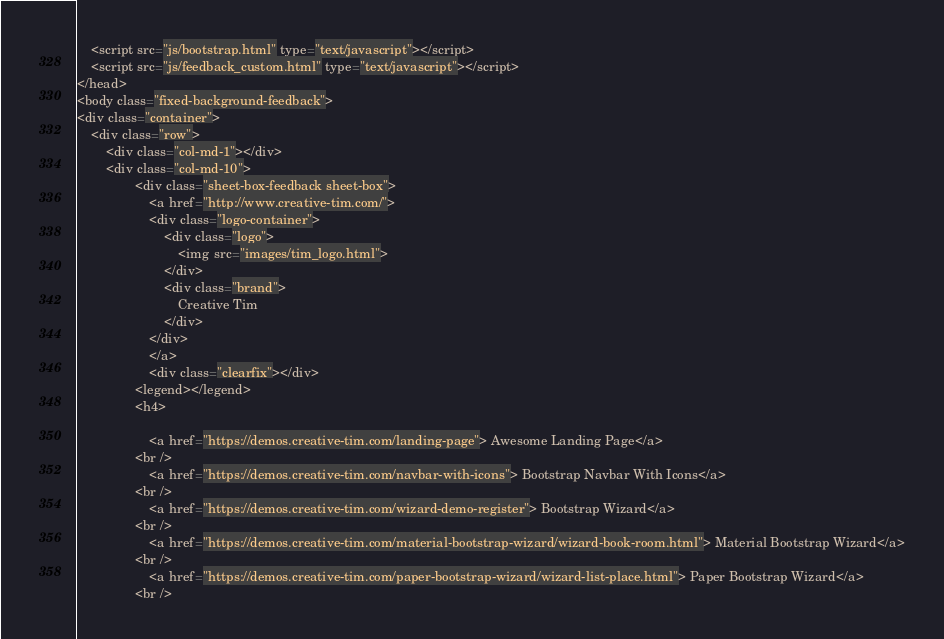Convert code to text. <code><loc_0><loc_0><loc_500><loc_500><_HTML_>	<script src="js/bootstrap.html" type="text/javascript"></script>
    <script src="js/feedback_custom.html" type="text/javascript"></script>
</head>
<body class="fixed-background-feedback">
<div class="container">
    <div class="row">
        <div class="col-md-1"></div>
        <div class="col-md-10">
                <div class="sheet-box-feedback sheet-box">
                    <a href="http://www.creative-tim.com/">
                    <div class="logo-container">
                        <div class="logo">
                            <img src="images/tim_logo.html">
                        </div>
                        <div class="brand">
                            Creative Tim
                        </div>
                    </div>
                    </a>
                    <div class="clearfix"></div>
                <legend></legend>
                <h4>

                    <a href="https://demos.creative-tim.com/landing-page"> Awesome Landing Page</a>
                <br />
                    <a href="https://demos.creative-tim.com/navbar-with-icons"> Bootstrap Navbar With Icons</a>
                <br />
                    <a href="https://demos.creative-tim.com/wizard-demo-register"> Bootstrap Wizard</a>
                <br />
					<a href="https://demos.creative-tim.com/material-bootstrap-wizard/wizard-book-room.html"> Material Bootstrap Wizard</a>
				<br />
					<a href="https://demos.creative-tim.com/paper-bootstrap-wizard/wizard-list-place.html"> Paper Bootstrap Wizard</a>
				<br /></code> 